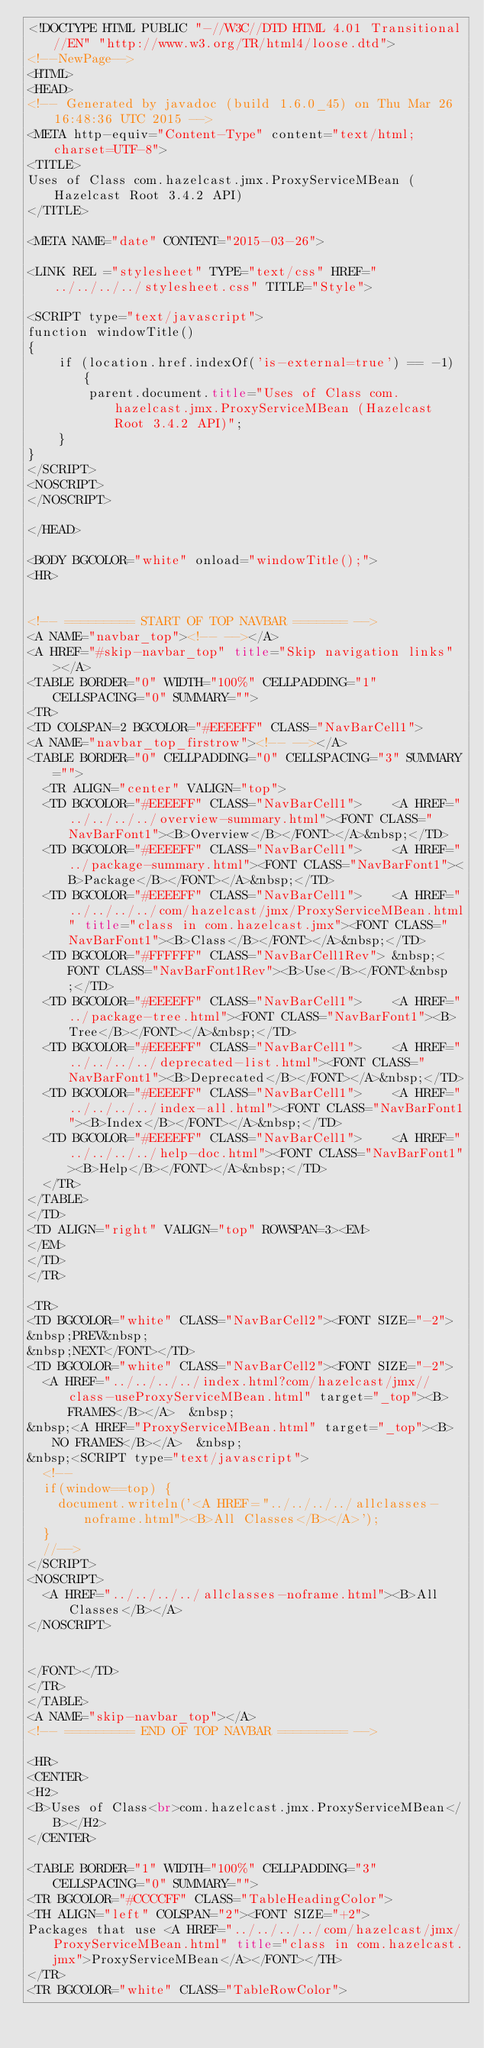<code> <loc_0><loc_0><loc_500><loc_500><_HTML_><!DOCTYPE HTML PUBLIC "-//W3C//DTD HTML 4.01 Transitional//EN" "http://www.w3.org/TR/html4/loose.dtd">
<!--NewPage-->
<HTML>
<HEAD>
<!-- Generated by javadoc (build 1.6.0_45) on Thu Mar 26 16:48:36 UTC 2015 -->
<META http-equiv="Content-Type" content="text/html; charset=UTF-8">
<TITLE>
Uses of Class com.hazelcast.jmx.ProxyServiceMBean (Hazelcast Root 3.4.2 API)
</TITLE>

<META NAME="date" CONTENT="2015-03-26">

<LINK REL ="stylesheet" TYPE="text/css" HREF="../../../../stylesheet.css" TITLE="Style">

<SCRIPT type="text/javascript">
function windowTitle()
{
    if (location.href.indexOf('is-external=true') == -1) {
        parent.document.title="Uses of Class com.hazelcast.jmx.ProxyServiceMBean (Hazelcast Root 3.4.2 API)";
    }
}
</SCRIPT>
<NOSCRIPT>
</NOSCRIPT>

</HEAD>

<BODY BGCOLOR="white" onload="windowTitle();">
<HR>


<!-- ========= START OF TOP NAVBAR ======= -->
<A NAME="navbar_top"><!-- --></A>
<A HREF="#skip-navbar_top" title="Skip navigation links"></A>
<TABLE BORDER="0" WIDTH="100%" CELLPADDING="1" CELLSPACING="0" SUMMARY="">
<TR>
<TD COLSPAN=2 BGCOLOR="#EEEEFF" CLASS="NavBarCell1">
<A NAME="navbar_top_firstrow"><!-- --></A>
<TABLE BORDER="0" CELLPADDING="0" CELLSPACING="3" SUMMARY="">
  <TR ALIGN="center" VALIGN="top">
  <TD BGCOLOR="#EEEEFF" CLASS="NavBarCell1">    <A HREF="../../../../overview-summary.html"><FONT CLASS="NavBarFont1"><B>Overview</B></FONT></A>&nbsp;</TD>
  <TD BGCOLOR="#EEEEFF" CLASS="NavBarCell1">    <A HREF="../package-summary.html"><FONT CLASS="NavBarFont1"><B>Package</B></FONT></A>&nbsp;</TD>
  <TD BGCOLOR="#EEEEFF" CLASS="NavBarCell1">    <A HREF="../../../../com/hazelcast/jmx/ProxyServiceMBean.html" title="class in com.hazelcast.jmx"><FONT CLASS="NavBarFont1"><B>Class</B></FONT></A>&nbsp;</TD>
  <TD BGCOLOR="#FFFFFF" CLASS="NavBarCell1Rev"> &nbsp;<FONT CLASS="NavBarFont1Rev"><B>Use</B></FONT>&nbsp;</TD>
  <TD BGCOLOR="#EEEEFF" CLASS="NavBarCell1">    <A HREF="../package-tree.html"><FONT CLASS="NavBarFont1"><B>Tree</B></FONT></A>&nbsp;</TD>
  <TD BGCOLOR="#EEEEFF" CLASS="NavBarCell1">    <A HREF="../../../../deprecated-list.html"><FONT CLASS="NavBarFont1"><B>Deprecated</B></FONT></A>&nbsp;</TD>
  <TD BGCOLOR="#EEEEFF" CLASS="NavBarCell1">    <A HREF="../../../../index-all.html"><FONT CLASS="NavBarFont1"><B>Index</B></FONT></A>&nbsp;</TD>
  <TD BGCOLOR="#EEEEFF" CLASS="NavBarCell1">    <A HREF="../../../../help-doc.html"><FONT CLASS="NavBarFont1"><B>Help</B></FONT></A>&nbsp;</TD>
  </TR>
</TABLE>
</TD>
<TD ALIGN="right" VALIGN="top" ROWSPAN=3><EM>
</EM>
</TD>
</TR>

<TR>
<TD BGCOLOR="white" CLASS="NavBarCell2"><FONT SIZE="-2">
&nbsp;PREV&nbsp;
&nbsp;NEXT</FONT></TD>
<TD BGCOLOR="white" CLASS="NavBarCell2"><FONT SIZE="-2">
  <A HREF="../../../../index.html?com/hazelcast/jmx//class-useProxyServiceMBean.html" target="_top"><B>FRAMES</B></A>  &nbsp;
&nbsp;<A HREF="ProxyServiceMBean.html" target="_top"><B>NO FRAMES</B></A>  &nbsp;
&nbsp;<SCRIPT type="text/javascript">
  <!--
  if(window==top) {
    document.writeln('<A HREF="../../../../allclasses-noframe.html"><B>All Classes</B></A>');
  }
  //-->
</SCRIPT>
<NOSCRIPT>
  <A HREF="../../../../allclasses-noframe.html"><B>All Classes</B></A>
</NOSCRIPT>


</FONT></TD>
</TR>
</TABLE>
<A NAME="skip-navbar_top"></A>
<!-- ========= END OF TOP NAVBAR ========= -->

<HR>
<CENTER>
<H2>
<B>Uses of Class<br>com.hazelcast.jmx.ProxyServiceMBean</B></H2>
</CENTER>

<TABLE BORDER="1" WIDTH="100%" CELLPADDING="3" CELLSPACING="0" SUMMARY="">
<TR BGCOLOR="#CCCCFF" CLASS="TableHeadingColor">
<TH ALIGN="left" COLSPAN="2"><FONT SIZE="+2">
Packages that use <A HREF="../../../../com/hazelcast/jmx/ProxyServiceMBean.html" title="class in com.hazelcast.jmx">ProxyServiceMBean</A></FONT></TH>
</TR>
<TR BGCOLOR="white" CLASS="TableRowColor"></code> 